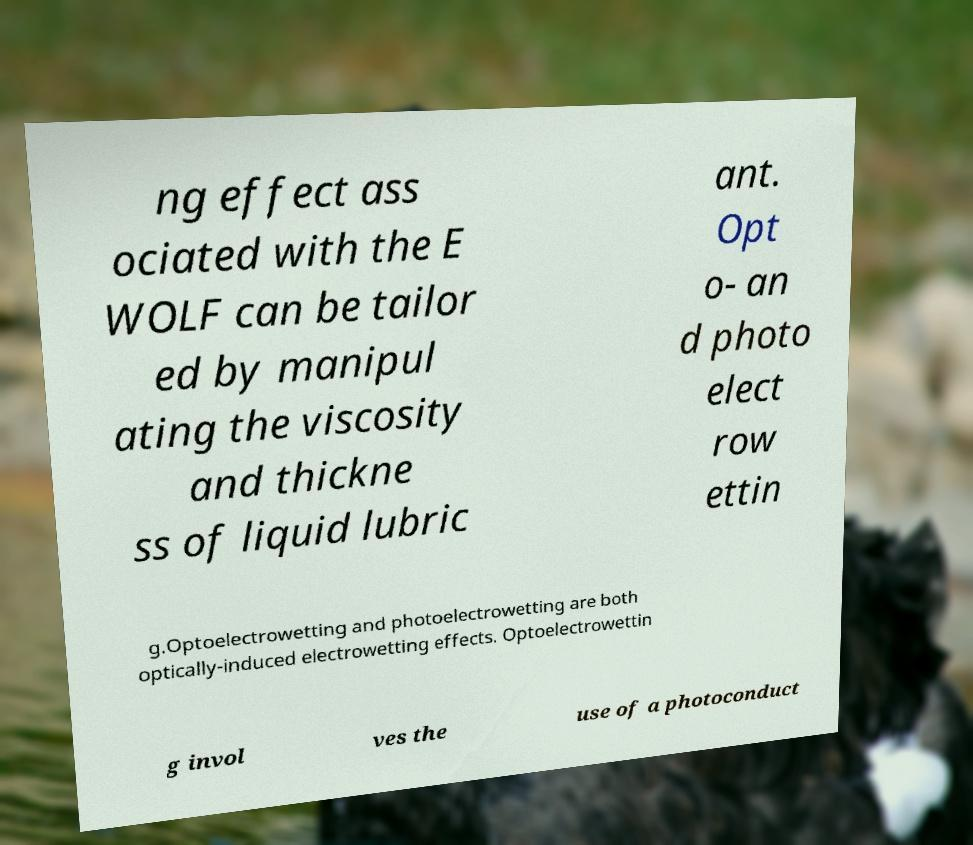Please identify and transcribe the text found in this image. ng effect ass ociated with the E WOLF can be tailor ed by manipul ating the viscosity and thickne ss of liquid lubric ant. Opt o- an d photo elect row ettin g.Optoelectrowetting and photoelectrowetting are both optically-induced electrowetting effects. Optoelectrowettin g invol ves the use of a photoconduct 